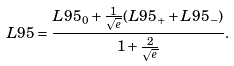Convert formula to latex. <formula><loc_0><loc_0><loc_500><loc_500>L 9 5 = \frac { L 9 5 _ { 0 } + \frac { 1 } { \sqrt { e } } ( L 9 5 _ { + } + L 9 5 _ { - } ) } { 1 + \frac { 2 } { \sqrt { e } } } .</formula> 